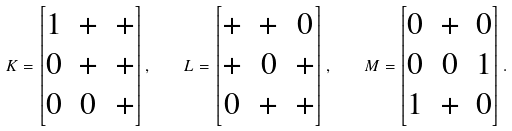<formula> <loc_0><loc_0><loc_500><loc_500>K = \begin{bmatrix} 1 & + & + \\ 0 & + & + \\ 0 & 0 & + \end{bmatrix} , \quad L = \begin{bmatrix} + & + & 0 \\ + & 0 & + \\ 0 & + & + \end{bmatrix} , \quad M = \begin{bmatrix} 0 & + & 0 \\ 0 & 0 & 1 \\ 1 & + & 0 \end{bmatrix} .</formula> 